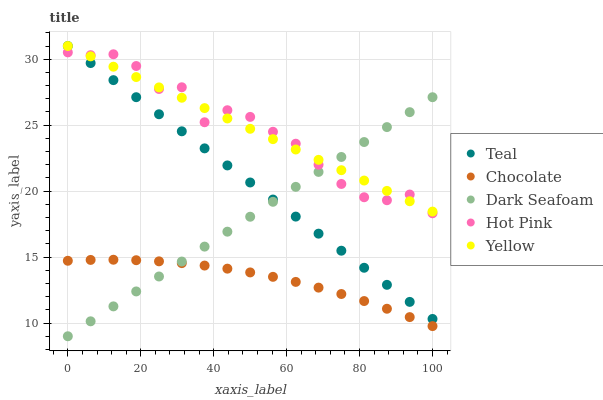Does Chocolate have the minimum area under the curve?
Answer yes or no. Yes. Does Hot Pink have the maximum area under the curve?
Answer yes or no. Yes. Does Yellow have the minimum area under the curve?
Answer yes or no. No. Does Yellow have the maximum area under the curve?
Answer yes or no. No. Is Dark Seafoam the smoothest?
Answer yes or no. Yes. Is Hot Pink the roughest?
Answer yes or no. Yes. Is Yellow the smoothest?
Answer yes or no. No. Is Yellow the roughest?
Answer yes or no. No. Does Dark Seafoam have the lowest value?
Answer yes or no. Yes. Does Hot Pink have the lowest value?
Answer yes or no. No. Does Teal have the highest value?
Answer yes or no. Yes. Does Hot Pink have the highest value?
Answer yes or no. No. Is Chocolate less than Teal?
Answer yes or no. Yes. Is Hot Pink greater than Chocolate?
Answer yes or no. Yes. Does Dark Seafoam intersect Yellow?
Answer yes or no. Yes. Is Dark Seafoam less than Yellow?
Answer yes or no. No. Is Dark Seafoam greater than Yellow?
Answer yes or no. No. Does Chocolate intersect Teal?
Answer yes or no. No. 